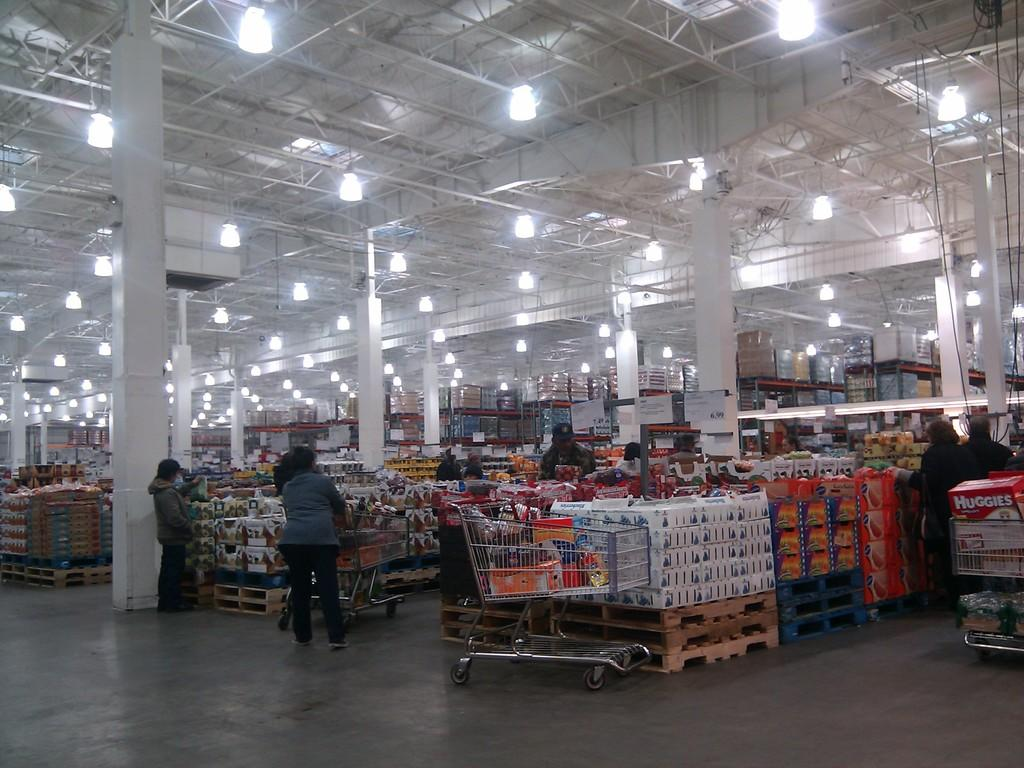Provide a one-sentence caption for the provided image. A person in a large wholesale supermarket has a box of Huggies in their trolley. 